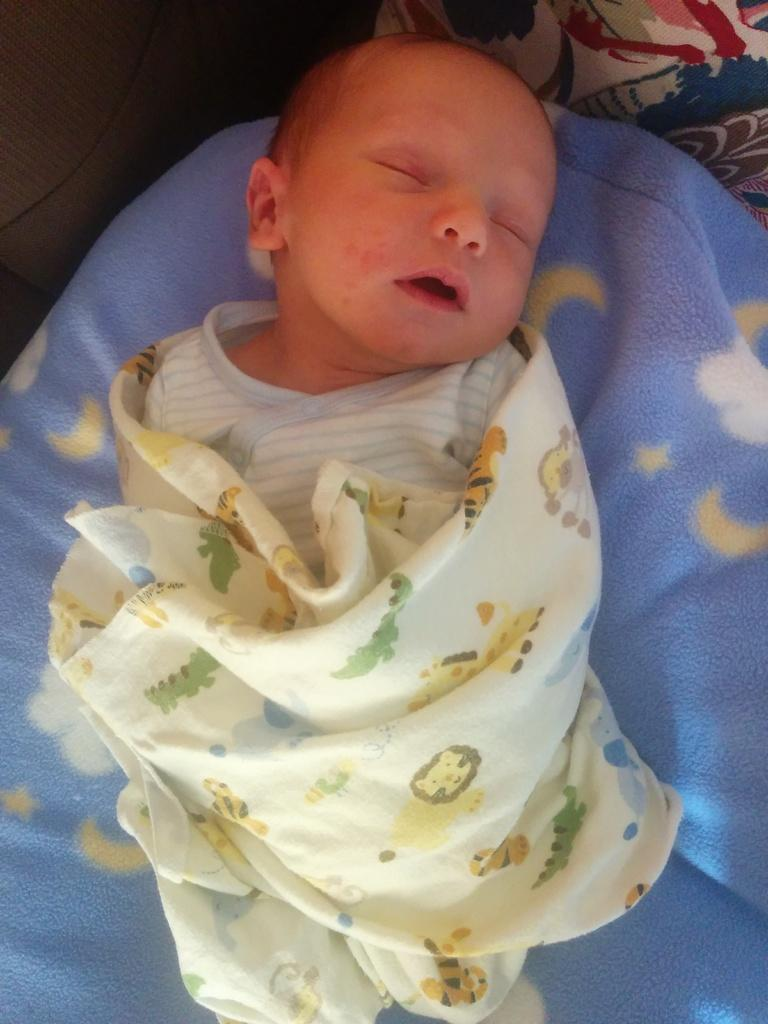What is the main subject of the image? The main subject of the image is a baby lying on the bed. Can you describe the baby's position or activity? The baby is lying on the bed. What else can be seen on the bed? There is an object on the bed. What color are the crayons that the baby is holding in the image? There are no crayons present in the image, and the baby is not holding anything. 